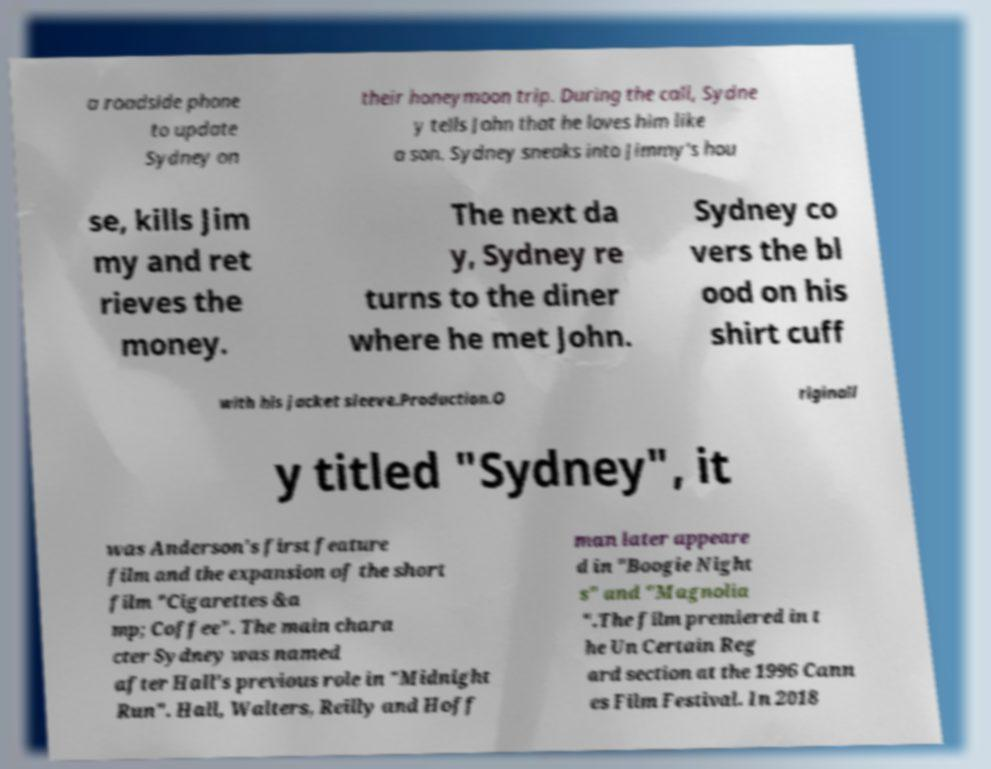What messages or text are displayed in this image? I need them in a readable, typed format. a roadside phone to update Sydney on their honeymoon trip. During the call, Sydne y tells John that he loves him like a son. Sydney sneaks into Jimmy's hou se, kills Jim my and ret rieves the money. The next da y, Sydney re turns to the diner where he met John. Sydney co vers the bl ood on his shirt cuff with his jacket sleeve.Production.O riginall y titled "Sydney", it was Anderson's first feature film and the expansion of the short film "Cigarettes &a mp; Coffee". The main chara cter Sydney was named after Hall's previous role in "Midnight Run". Hall, Walters, Reilly and Hoff man later appeare d in "Boogie Night s" and "Magnolia ".The film premiered in t he Un Certain Reg ard section at the 1996 Cann es Film Festival. In 2018 